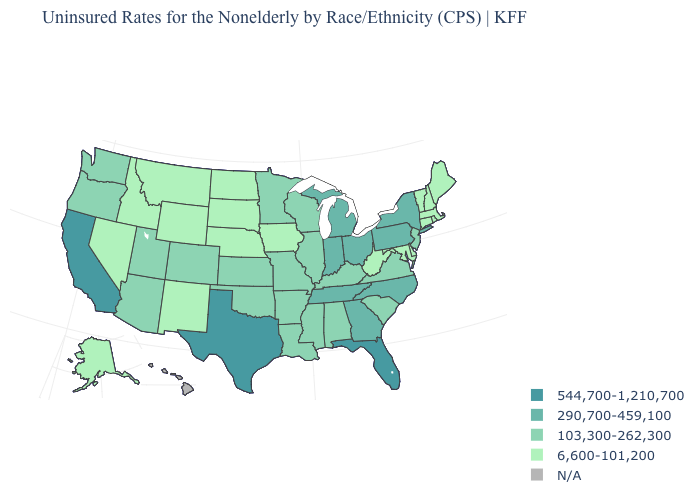Is the legend a continuous bar?
Concise answer only. No. Is the legend a continuous bar?
Keep it brief. No. What is the value of Louisiana?
Give a very brief answer. 103,300-262,300. Name the states that have a value in the range 290,700-459,100?
Write a very short answer. Georgia, Indiana, Michigan, New York, North Carolina, Ohio, Pennsylvania, Tennessee. Which states have the highest value in the USA?
Be succinct. California, Florida, Texas. What is the highest value in the West ?
Write a very short answer. 544,700-1,210,700. Which states hav the highest value in the West?
Short answer required. California. What is the highest value in states that border Tennessee?
Quick response, please. 290,700-459,100. Does the map have missing data?
Answer briefly. Yes. Name the states that have a value in the range 544,700-1,210,700?
Quick response, please. California, Florida, Texas. What is the value of Nebraska?
Be succinct. 6,600-101,200. Name the states that have a value in the range N/A?
Quick response, please. Hawaii. Name the states that have a value in the range 290,700-459,100?
Concise answer only. Georgia, Indiana, Michigan, New York, North Carolina, Ohio, Pennsylvania, Tennessee. Which states have the highest value in the USA?
Write a very short answer. California, Florida, Texas. What is the value of Missouri?
Write a very short answer. 103,300-262,300. 